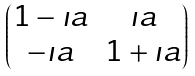<formula> <loc_0><loc_0><loc_500><loc_500>\begin{pmatrix} 1 - \imath a & \imath a \\ - \imath a & 1 + \imath a \end{pmatrix}</formula> 